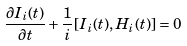<formula> <loc_0><loc_0><loc_500><loc_500>\frac { \partial I _ { i } ( t ) } { \partial t } + \frac { 1 } { i } [ I _ { i } ( t ) , H _ { i } ( t ) ] = 0</formula> 